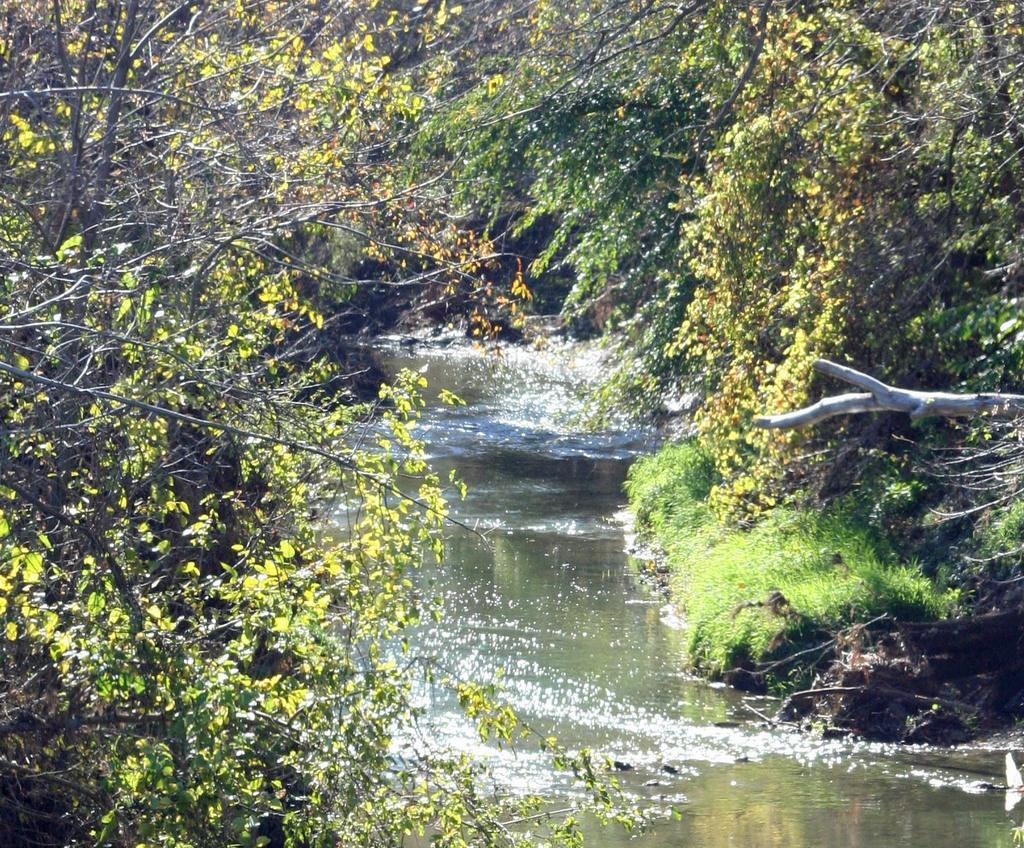Describe this image in one or two sentences. In this image we can see water and there are some trees on left and right side of the image. 